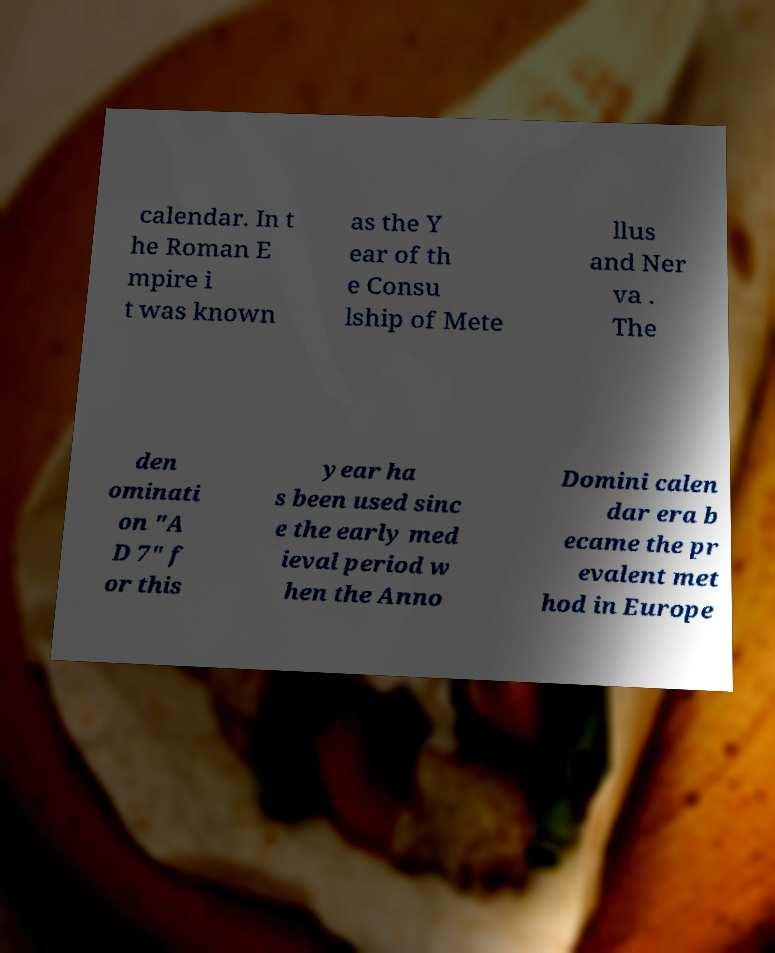Could you assist in decoding the text presented in this image and type it out clearly? calendar. In t he Roman E mpire i t was known as the Y ear of th e Consu lship of Mete llus and Ner va . The den ominati on "A D 7" f or this year ha s been used sinc e the early med ieval period w hen the Anno Domini calen dar era b ecame the pr evalent met hod in Europe 